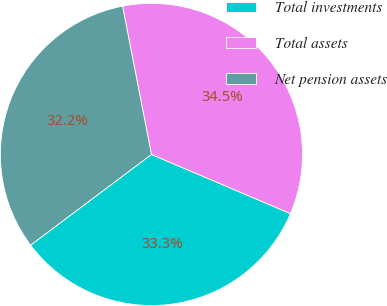<chart> <loc_0><loc_0><loc_500><loc_500><pie_chart><fcel>Total investments<fcel>Total assets<fcel>Net pension assets<nl><fcel>33.35%<fcel>34.47%<fcel>32.18%<nl></chart> 